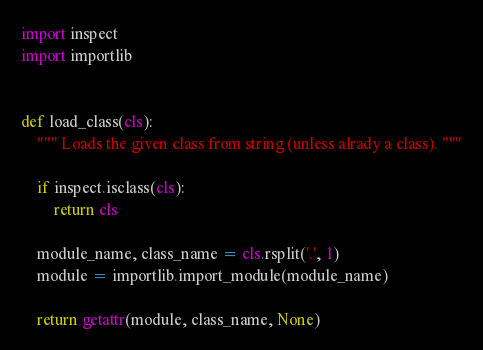<code> <loc_0><loc_0><loc_500><loc_500><_Python_>import inspect
import importlib


def load_class(cls):
    """ Loads the given class from string (unless alrady a class). """

    if inspect.isclass(cls):
        return cls

    module_name, class_name = cls.rsplit('.', 1)
    module = importlib.import_module(module_name)

    return getattr(module, class_name, None)
</code> 